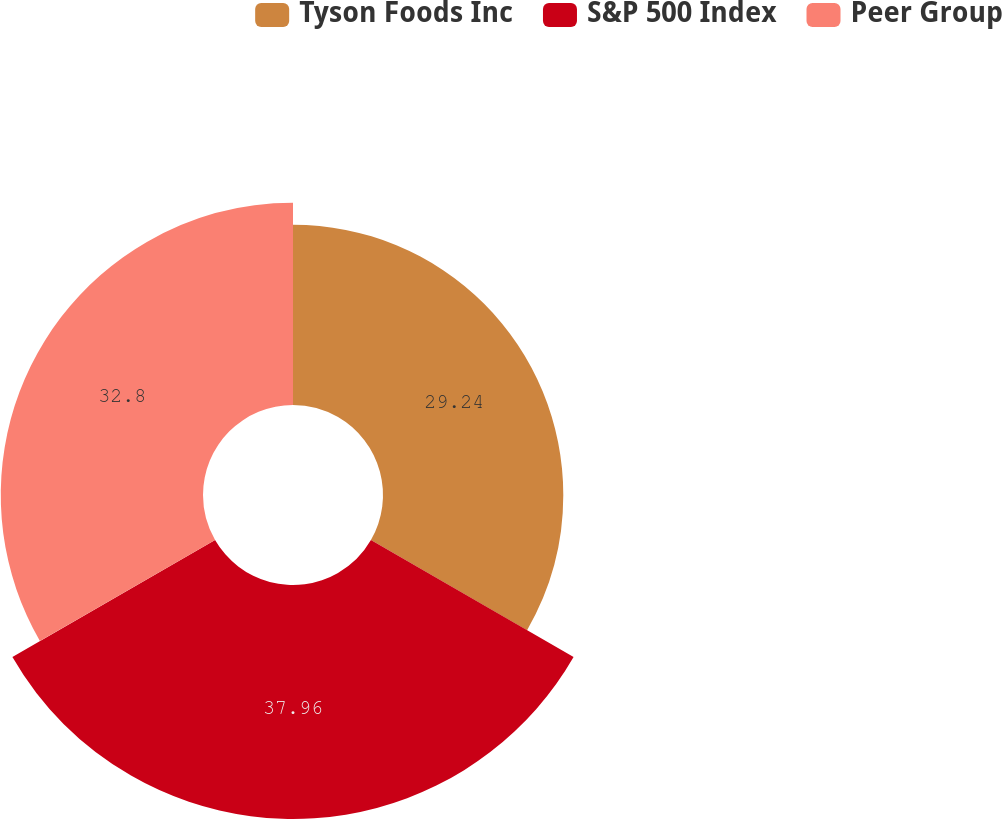Convert chart. <chart><loc_0><loc_0><loc_500><loc_500><pie_chart><fcel>Tyson Foods Inc<fcel>S&P 500 Index<fcel>Peer Group<nl><fcel>29.24%<fcel>37.95%<fcel>32.8%<nl></chart> 